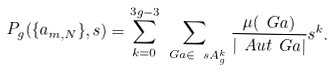Convert formula to latex. <formula><loc_0><loc_0><loc_500><loc_500>P _ { g } ( \{ a _ { m , N } \} , s ) = \sum _ { k = 0 } ^ { 3 g - 3 } \sum _ { \ G a \in \ s A _ { g } ^ { k } } \frac { \mu ( \ G a ) } { | \ A u t \ G a | } s ^ { k } .</formula> 